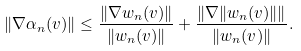<formula> <loc_0><loc_0><loc_500><loc_500>\| \nabla \alpha _ { n } ( v ) \| \leq \frac { \| \nabla w _ { n } ( v ) \| } { \| w _ { n } ( v ) \| } + \frac { \| \nabla \| w _ { n } ( v ) \| \| } { \| w _ { n } ( v ) \| } .</formula> 